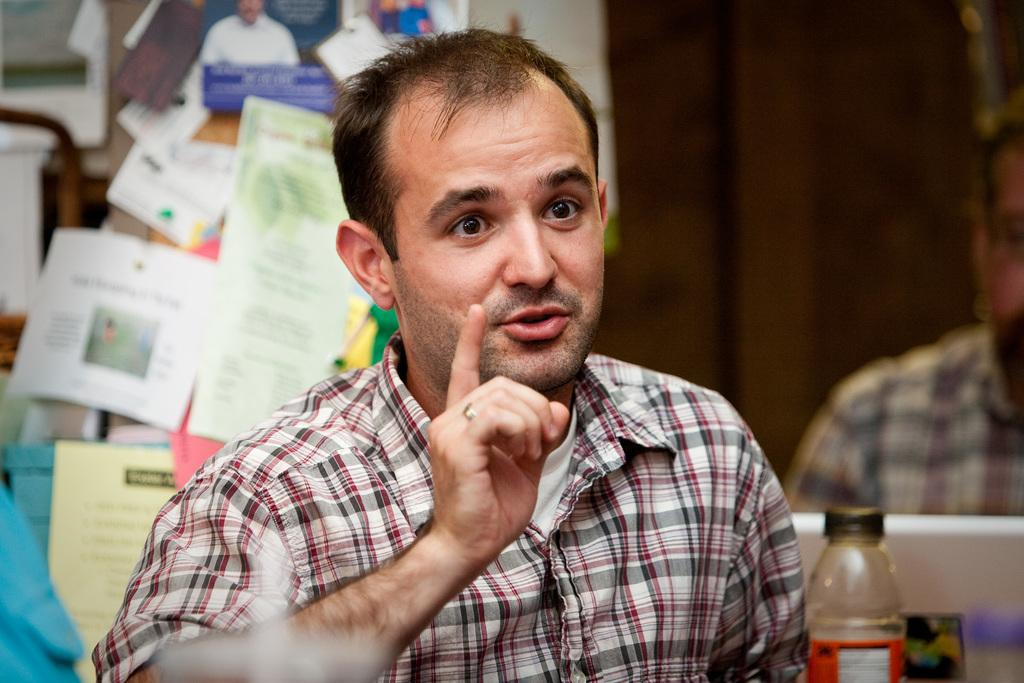How many people are present in the image? There are two people in the image. What can be seen on the wall in the background of the image? There are papers on the wall in the background of the image. What type of bell can be heard ringing in the image? There is no bell present or ringing in the image. How does the van in the image turn around the corner? There is no van present in the image. 